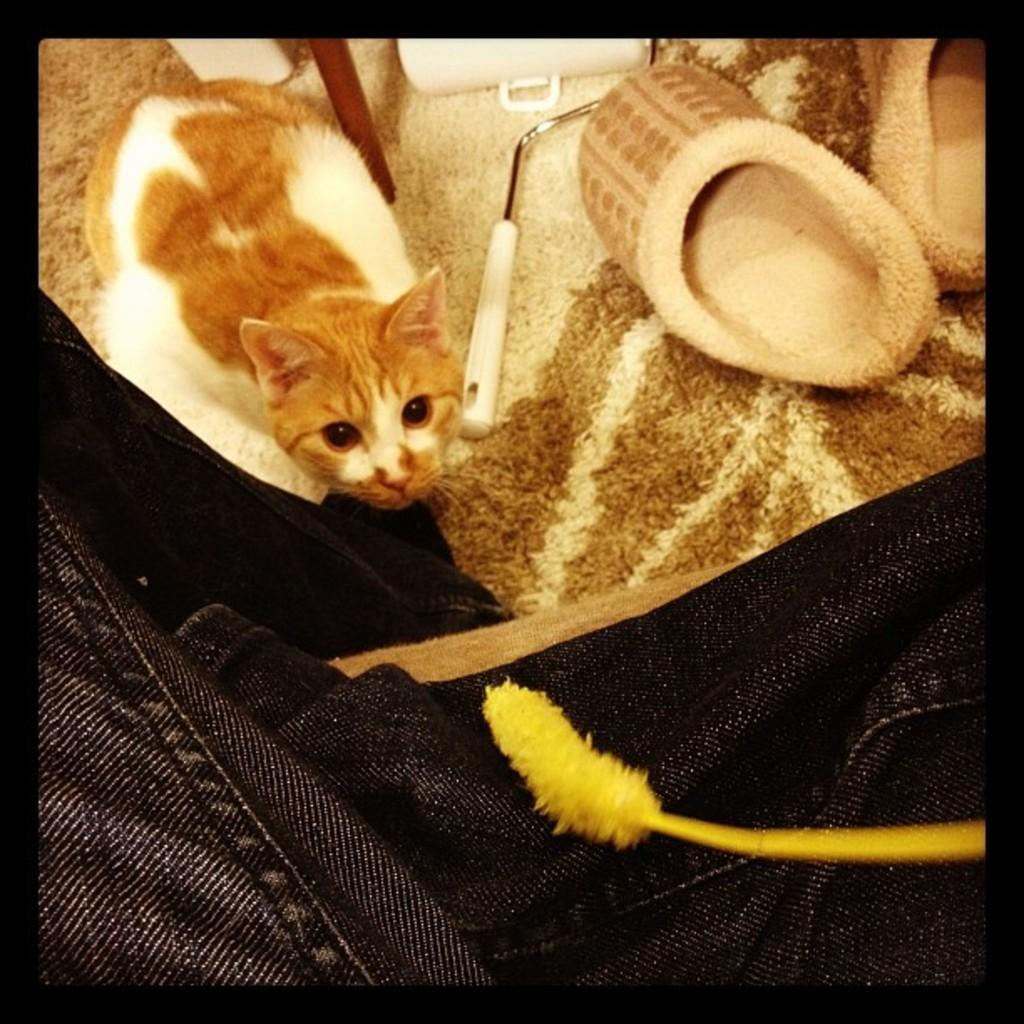What type of animal is in the image? There is a cat in the image. Can you describe the color pattern of the cat? The cat has brown and white colors. What can be seen on the surface in the image? There are objects on a cream and brown color surface in the image. What type of cap is the crook wearing in the image? There is no crook or cap present in the image; it features a cat with brown and white colors on a cream and brown color surface. 